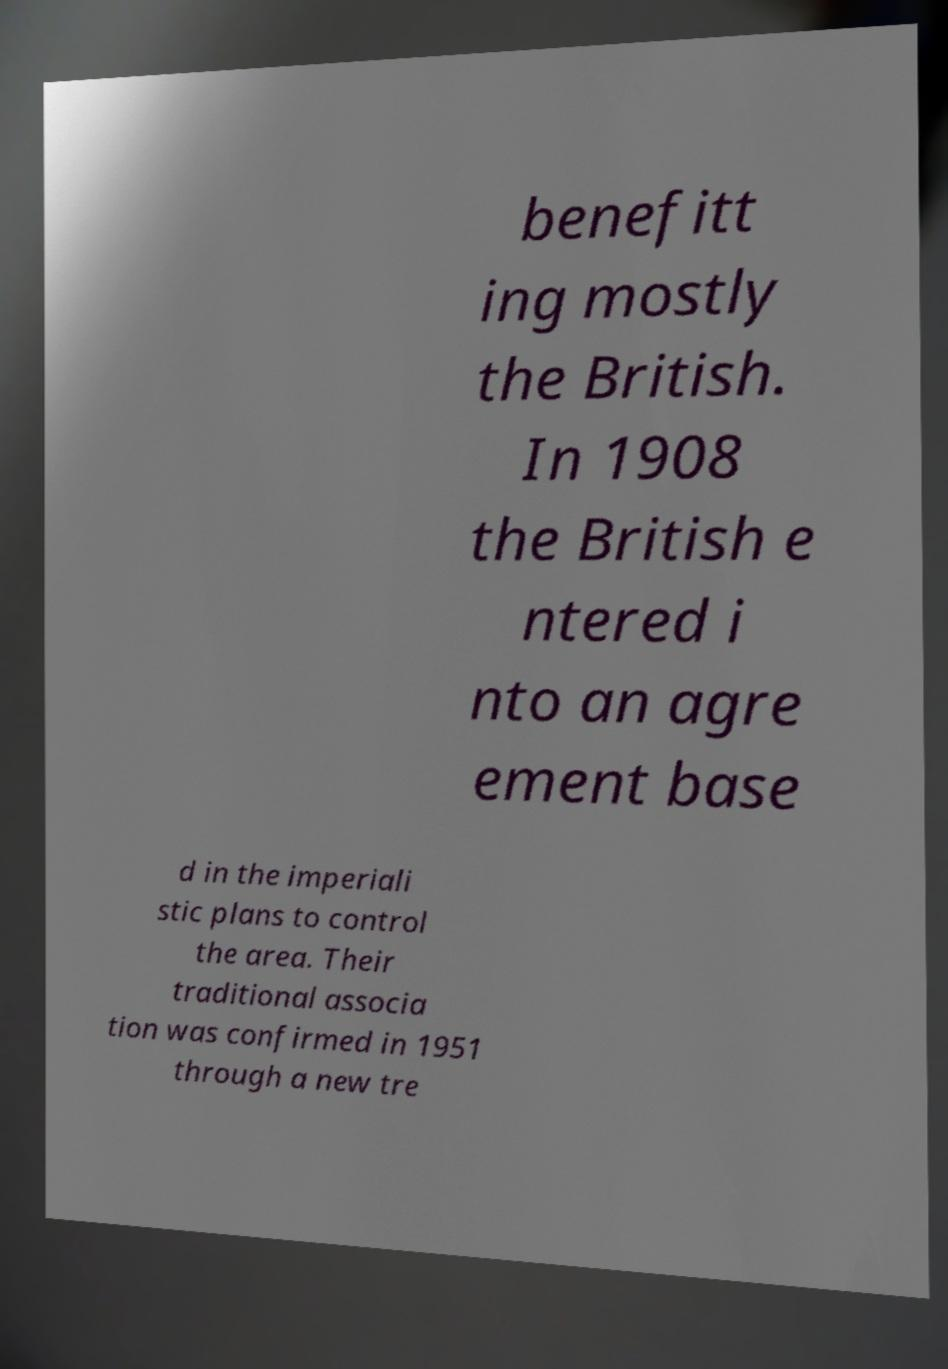What messages or text are displayed in this image? I need them in a readable, typed format. benefitt ing mostly the British. In 1908 the British e ntered i nto an agre ement base d in the imperiali stic plans to control the area. Their traditional associa tion was confirmed in 1951 through a new tre 